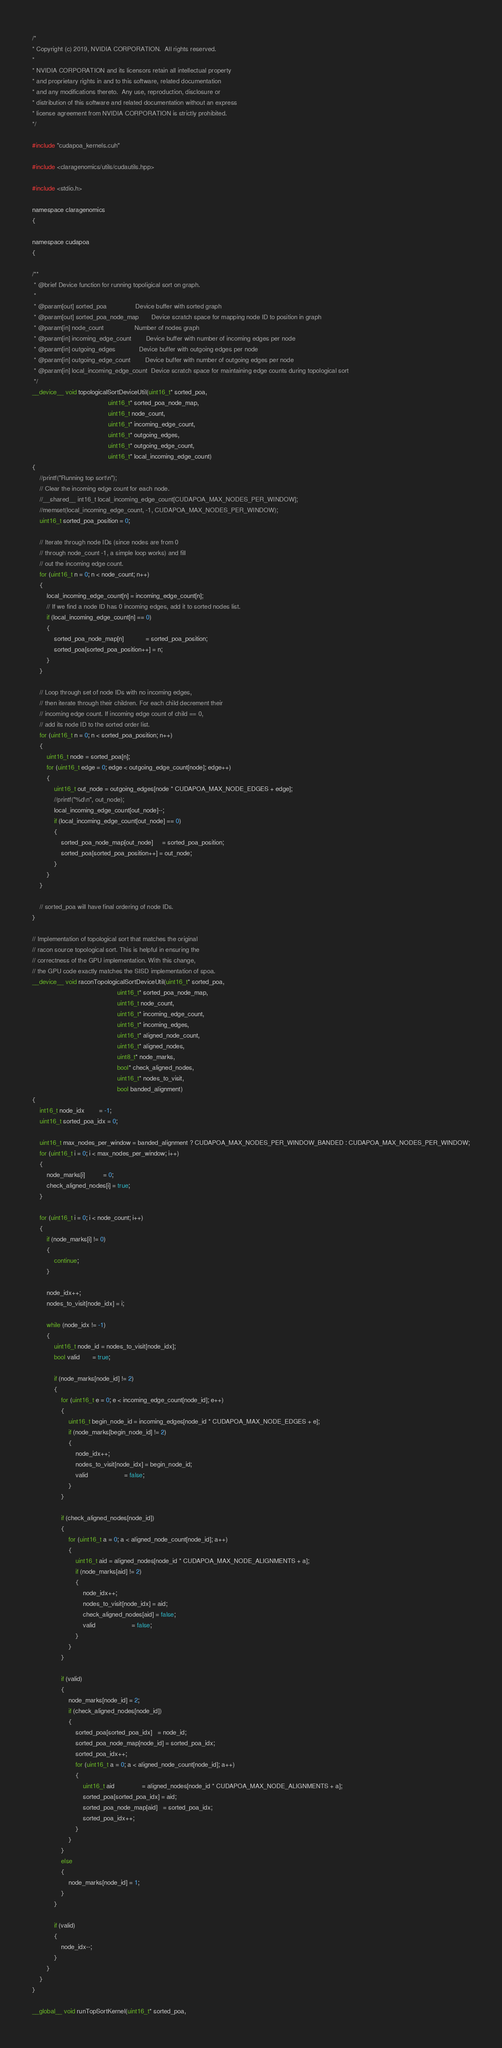Convert code to text. <code><loc_0><loc_0><loc_500><loc_500><_Cuda_>/*
* Copyright (c) 2019, NVIDIA CORPORATION.  All rights reserved.
*
* NVIDIA CORPORATION and its licensors retain all intellectual property
* and proprietary rights in and to this software, related documentation
* and any modifications thereto.  Any use, reproduction, disclosure or
* distribution of this software and related documentation without an express
* license agreement from NVIDIA CORPORATION is strictly prohibited.
*/

#include "cudapoa_kernels.cuh"

#include <claragenomics/utils/cudautils.hpp>

#include <stdio.h>

namespace claragenomics
{

namespace cudapoa
{

/**
 * @brief Device function for running topoligical sort on graph.
 *
 * @param[out] sorted_poa                Device buffer with sorted graph
 * @param[out] sorted_poa_node_map       Device scratch space for mapping node ID to position in graph
 * @param[in] node_count                 Number of nodes graph
 * @param[in] incoming_edge_count        Device buffer with number of incoming edges per node
 * @param[in] outgoing_edges             Device buffer with outgoing edges per node
 * @param[in] outgoing_edge_count        Device buffer with number of outgoing edges per node
 * @param[in] local_incoming_edge_count  Device scratch space for maintaining edge counts during topological sort
 */
__device__ void topologicalSortDeviceUtil(uint16_t* sorted_poa,
                                          uint16_t* sorted_poa_node_map,
                                          uint16_t node_count,
                                          uint16_t* incoming_edge_count,
                                          uint16_t* outgoing_edges,
                                          uint16_t* outgoing_edge_count,
                                          uint16_t* local_incoming_edge_count)
{
    //printf("Running top sort\n");
    // Clear the incoming edge count for each node.
    //__shared__ int16_t local_incoming_edge_count[CUDAPOA_MAX_NODES_PER_WINDOW];
    //memset(local_incoming_edge_count, -1, CUDAPOA_MAX_NODES_PER_WINDOW);
    uint16_t sorted_poa_position = 0;

    // Iterate through node IDs (since nodes are from 0
    // through node_count -1, a simple loop works) and fill
    // out the incoming edge count.
    for (uint16_t n = 0; n < node_count; n++)
    {
        local_incoming_edge_count[n] = incoming_edge_count[n];
        // If we find a node ID has 0 incoming edges, add it to sorted nodes list.
        if (local_incoming_edge_count[n] == 0)
        {
            sorted_poa_node_map[n]            = sorted_poa_position;
            sorted_poa[sorted_poa_position++] = n;
        }
    }

    // Loop through set of node IDs with no incoming edges,
    // then iterate through their children. For each child decrement their
    // incoming edge count. If incoming edge count of child == 0,
    // add its node ID to the sorted order list.
    for (uint16_t n = 0; n < sorted_poa_position; n++)
    {
        uint16_t node = sorted_poa[n];
        for (uint16_t edge = 0; edge < outgoing_edge_count[node]; edge++)
        {
            uint16_t out_node = outgoing_edges[node * CUDAPOA_MAX_NODE_EDGES + edge];
            //printf("%d\n", out_node);
            local_incoming_edge_count[out_node]--;
            if (local_incoming_edge_count[out_node] == 0)
            {
                sorted_poa_node_map[out_node]     = sorted_poa_position;
                sorted_poa[sorted_poa_position++] = out_node;
            }
        }
    }

    // sorted_poa will have final ordering of node IDs.
}

// Implementation of topological sort that matches the original
// racon source topological sort. This is helpful in ensuring the
// correctness of the GPU implementation. With this change,
// the GPU code exactly matches the SISD implementation of spoa.
__device__ void raconTopologicalSortDeviceUtil(uint16_t* sorted_poa,
                                               uint16_t* sorted_poa_node_map,
                                               uint16_t node_count,
                                               uint16_t* incoming_edge_count,
                                               uint16_t* incoming_edges,
                                               uint16_t* aligned_node_count,
                                               uint16_t* aligned_nodes,
                                               uint8_t* node_marks,
                                               bool* check_aligned_nodes,
                                               uint16_t* nodes_to_visit,
                                               bool banded_alignment)
{
    int16_t node_idx        = -1;
    uint16_t sorted_poa_idx = 0;

    uint16_t max_nodes_per_window = banded_alignment ? CUDAPOA_MAX_NODES_PER_WINDOW_BANDED : CUDAPOA_MAX_NODES_PER_WINDOW;
    for (uint16_t i = 0; i < max_nodes_per_window; i++)
    {
        node_marks[i]          = 0;
        check_aligned_nodes[i] = true;
    }

    for (uint16_t i = 0; i < node_count; i++)
    {
        if (node_marks[i] != 0)
        {
            continue;
        }

        node_idx++;
        nodes_to_visit[node_idx] = i;

        while (node_idx != -1)
        {
            uint16_t node_id = nodes_to_visit[node_idx];
            bool valid       = true;

            if (node_marks[node_id] != 2)
            {
                for (uint16_t e = 0; e < incoming_edge_count[node_id]; e++)
                {
                    uint16_t begin_node_id = incoming_edges[node_id * CUDAPOA_MAX_NODE_EDGES + e];
                    if (node_marks[begin_node_id] != 2)
                    {
                        node_idx++;
                        nodes_to_visit[node_idx] = begin_node_id;
                        valid                    = false;
                    }
                }

                if (check_aligned_nodes[node_id])
                {
                    for (uint16_t a = 0; a < aligned_node_count[node_id]; a++)
                    {
                        uint16_t aid = aligned_nodes[node_id * CUDAPOA_MAX_NODE_ALIGNMENTS + a];
                        if (node_marks[aid] != 2)
                        {
                            node_idx++;
                            nodes_to_visit[node_idx] = aid;
                            check_aligned_nodes[aid] = false;
                            valid                    = false;
                        }
                    }
                }

                if (valid)
                {
                    node_marks[node_id] = 2;
                    if (check_aligned_nodes[node_id])
                    {
                        sorted_poa[sorted_poa_idx]   = node_id;
                        sorted_poa_node_map[node_id] = sorted_poa_idx;
                        sorted_poa_idx++;
                        for (uint16_t a = 0; a < aligned_node_count[node_id]; a++)
                        {
                            uint16_t aid               = aligned_nodes[node_id * CUDAPOA_MAX_NODE_ALIGNMENTS + a];
                            sorted_poa[sorted_poa_idx] = aid;
                            sorted_poa_node_map[aid]   = sorted_poa_idx;
                            sorted_poa_idx++;
                        }
                    }
                }
                else
                {
                    node_marks[node_id] = 1;
                }
            }

            if (valid)
            {
                node_idx--;
            }
        }
    }
}

__global__ void runTopSortKernel(uint16_t* sorted_poa,</code> 